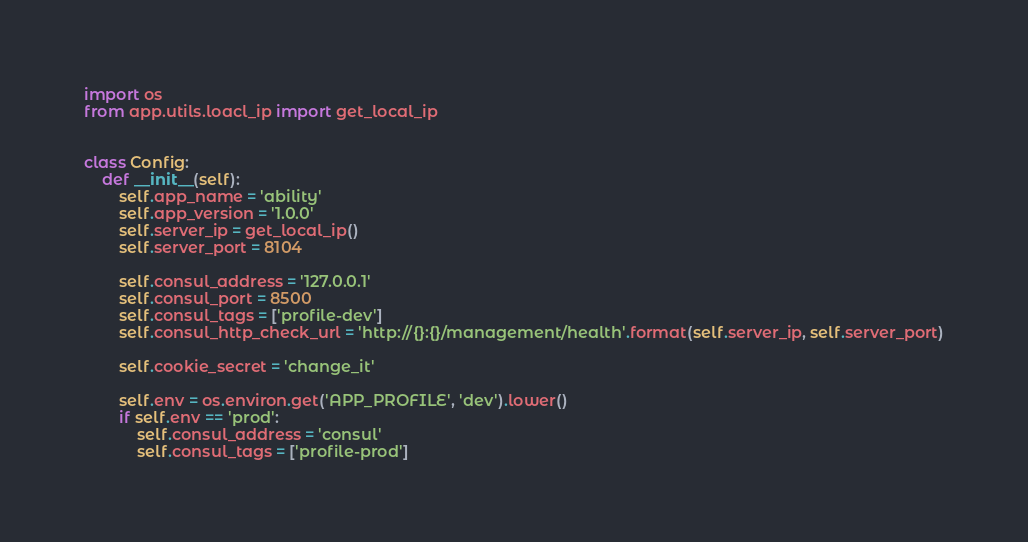Convert code to text. <code><loc_0><loc_0><loc_500><loc_500><_Python_>import os
from app.utils.loacl_ip import get_local_ip


class Config:
    def __init__(self):
        self.app_name = 'ability'
        self.app_version = '1.0.0'
        self.server_ip = get_local_ip()
        self.server_port = 8104

        self.consul_address = '127.0.0.1'
        self.consul_port = 8500
        self.consul_tags = ['profile-dev']
        self.consul_http_check_url = 'http://{}:{}/management/health'.format(self.server_ip, self.server_port)

        self.cookie_secret = 'change_it'

        self.env = os.environ.get('APP_PROFILE', 'dev').lower()
        if self.env == 'prod':
            self.consul_address = 'consul'
            self.consul_tags = ['profile-prod']

</code> 